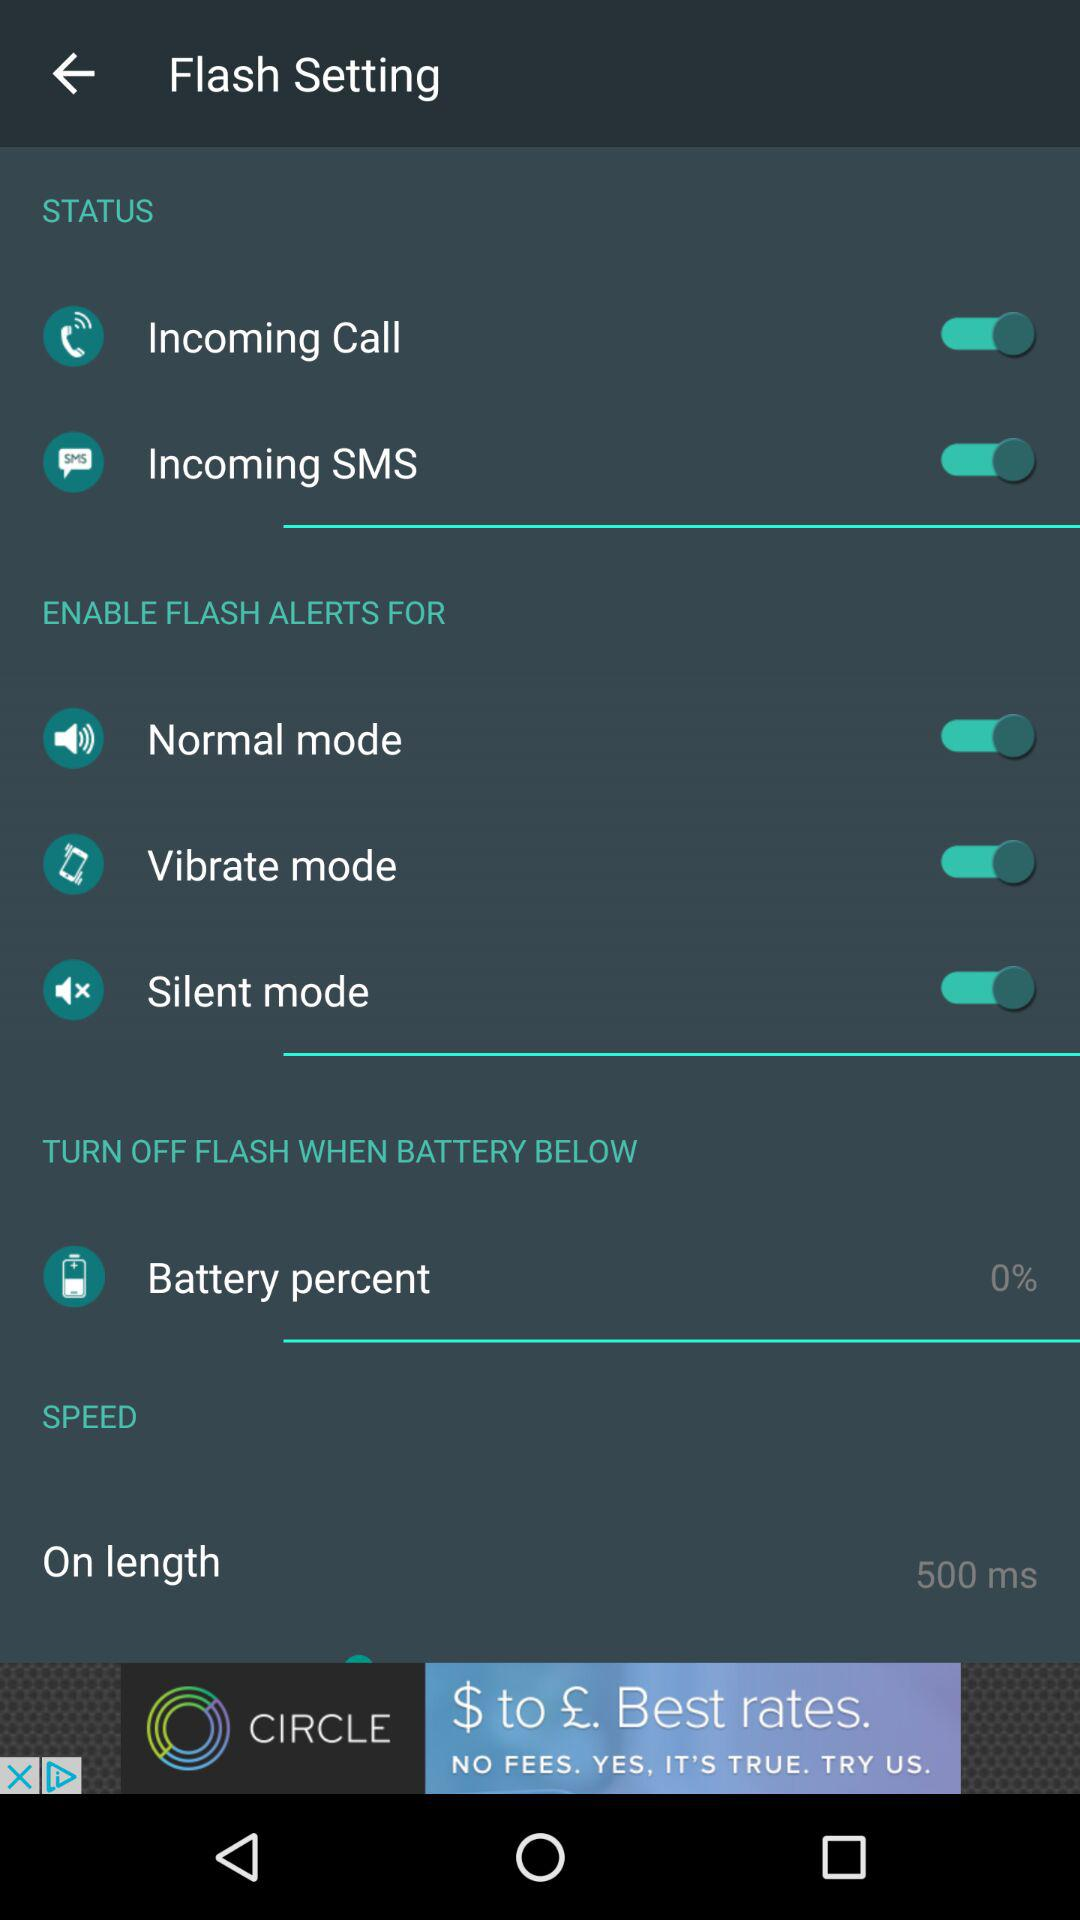Which modes are available? The available modes are "Normal mode", "Vibrate mode" and "Silent mode". 